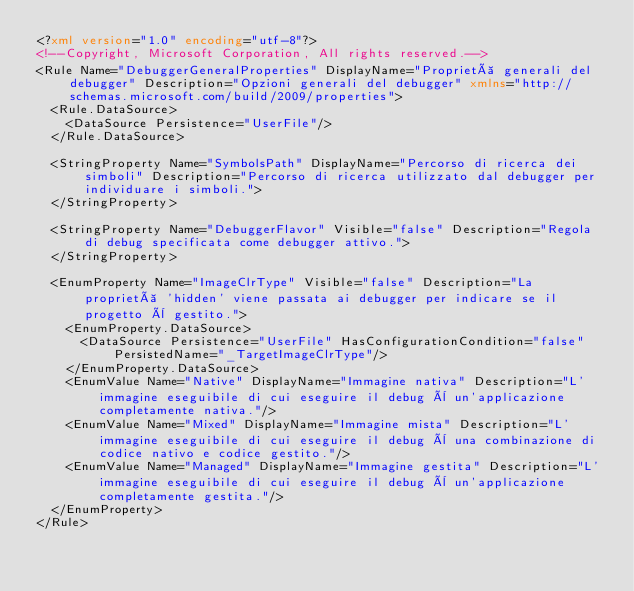<code> <loc_0><loc_0><loc_500><loc_500><_XML_><?xml version="1.0" encoding="utf-8"?>
<!--Copyright, Microsoft Corporation, All rights reserved.-->
<Rule Name="DebuggerGeneralProperties" DisplayName="Proprietà generali del debugger" Description="Opzioni generali del debugger" xmlns="http://schemas.microsoft.com/build/2009/properties">
  <Rule.DataSource>
    <DataSource Persistence="UserFile"/>
  </Rule.DataSource>
  
  <StringProperty Name="SymbolsPath" DisplayName="Percorso di ricerca dei simboli" Description="Percorso di ricerca utilizzato dal debugger per individuare i simboli.">
  </StringProperty>

  <StringProperty Name="DebuggerFlavor" Visible="false" Description="Regola di debug specificata come debugger attivo.">
  </StringProperty>

  <EnumProperty Name="ImageClrType" Visible="false" Description="La proprietà 'hidden' viene passata ai debugger per indicare se il progetto è gestito.">
    <EnumProperty.DataSource>
      <DataSource Persistence="UserFile" HasConfigurationCondition="false" PersistedName="_TargetImageClrType"/>
    </EnumProperty.DataSource>
    <EnumValue Name="Native" DisplayName="Immagine nativa" Description="L'immagine eseguibile di cui eseguire il debug è un'applicazione completamente nativa."/>
    <EnumValue Name="Mixed" DisplayName="Immagine mista" Description="L'immagine eseguibile di cui eseguire il debug è una combinazione di codice nativo e codice gestito."/>
    <EnumValue Name="Managed" DisplayName="Immagine gestita" Description="L'immagine eseguibile di cui eseguire il debug è un'applicazione completamente gestita."/>
  </EnumProperty>
</Rule>
</code> 